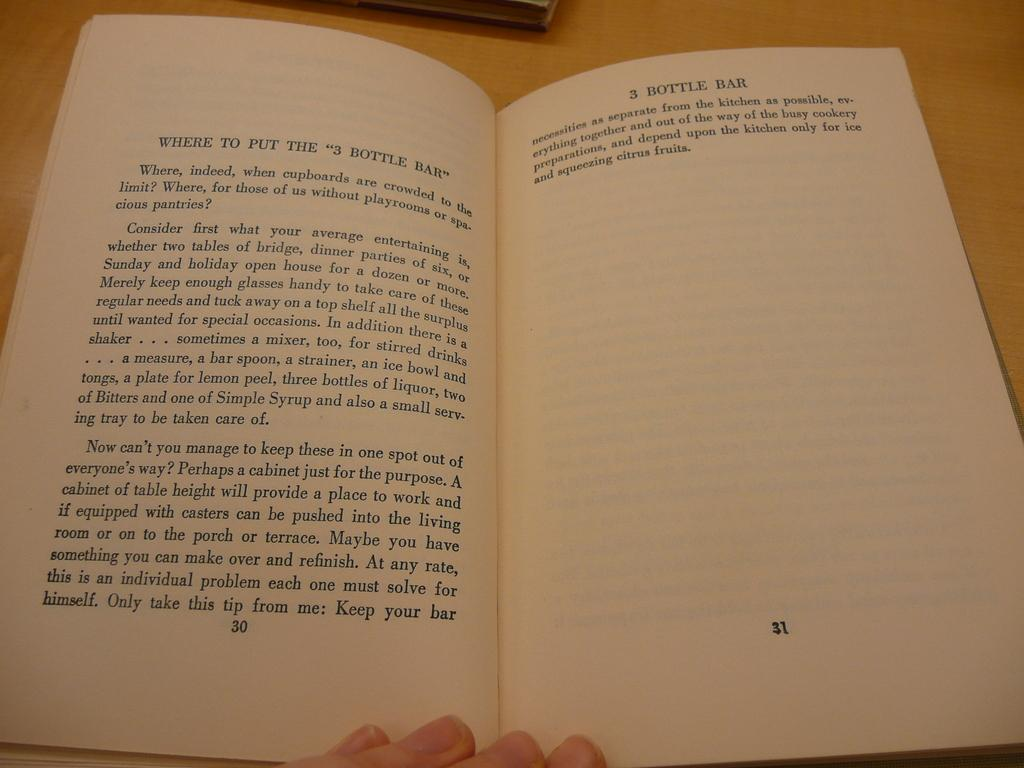<image>
Describe the image concisely. a book with the page titled 'bottle bar' at the top 